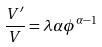Convert formula to latex. <formula><loc_0><loc_0><loc_500><loc_500>\frac { V ^ { \prime } } { V } = \lambda \alpha \phi ^ { \alpha - 1 }</formula> 